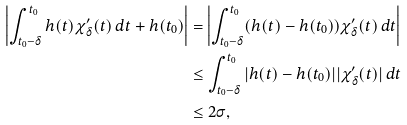<formula> <loc_0><loc_0><loc_500><loc_500>\left | \int _ { t _ { 0 } - \delta } ^ { t _ { 0 } } h ( t ) \chi ^ { \prime } _ { \delta } ( t ) \, d t + h ( t _ { 0 } ) \right | & = \left | \int _ { t _ { 0 } - \delta } ^ { t _ { 0 } } ( h ( t ) - h ( t _ { 0 } ) ) \chi ^ { \prime } _ { \delta } ( t ) \, d t \right | \\ & \leq \int _ { t _ { 0 } - \delta } ^ { t _ { 0 } } | h ( t ) - h ( t _ { 0 } ) | | \chi ^ { \prime } _ { \delta } ( t ) | \, d t \\ & \leq 2 \sigma ,</formula> 